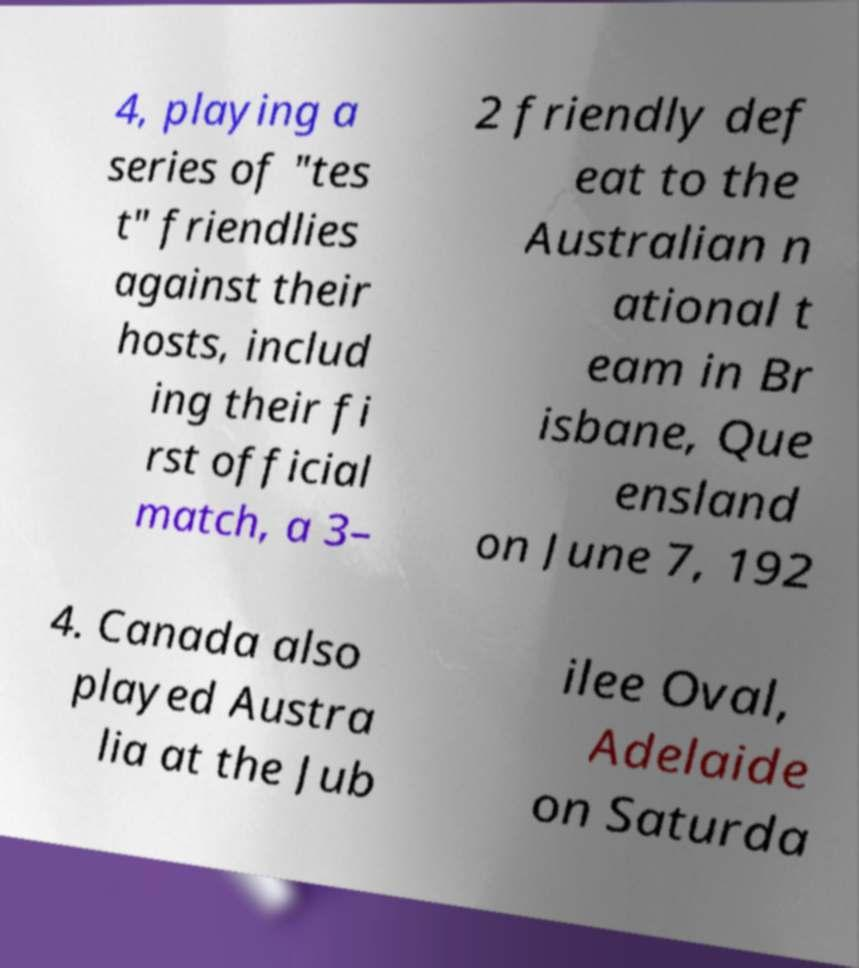For documentation purposes, I need the text within this image transcribed. Could you provide that? 4, playing a series of "tes t" friendlies against their hosts, includ ing their fi rst official match, a 3– 2 friendly def eat to the Australian n ational t eam in Br isbane, Que ensland on June 7, 192 4. Canada also played Austra lia at the Jub ilee Oval, Adelaide on Saturda 